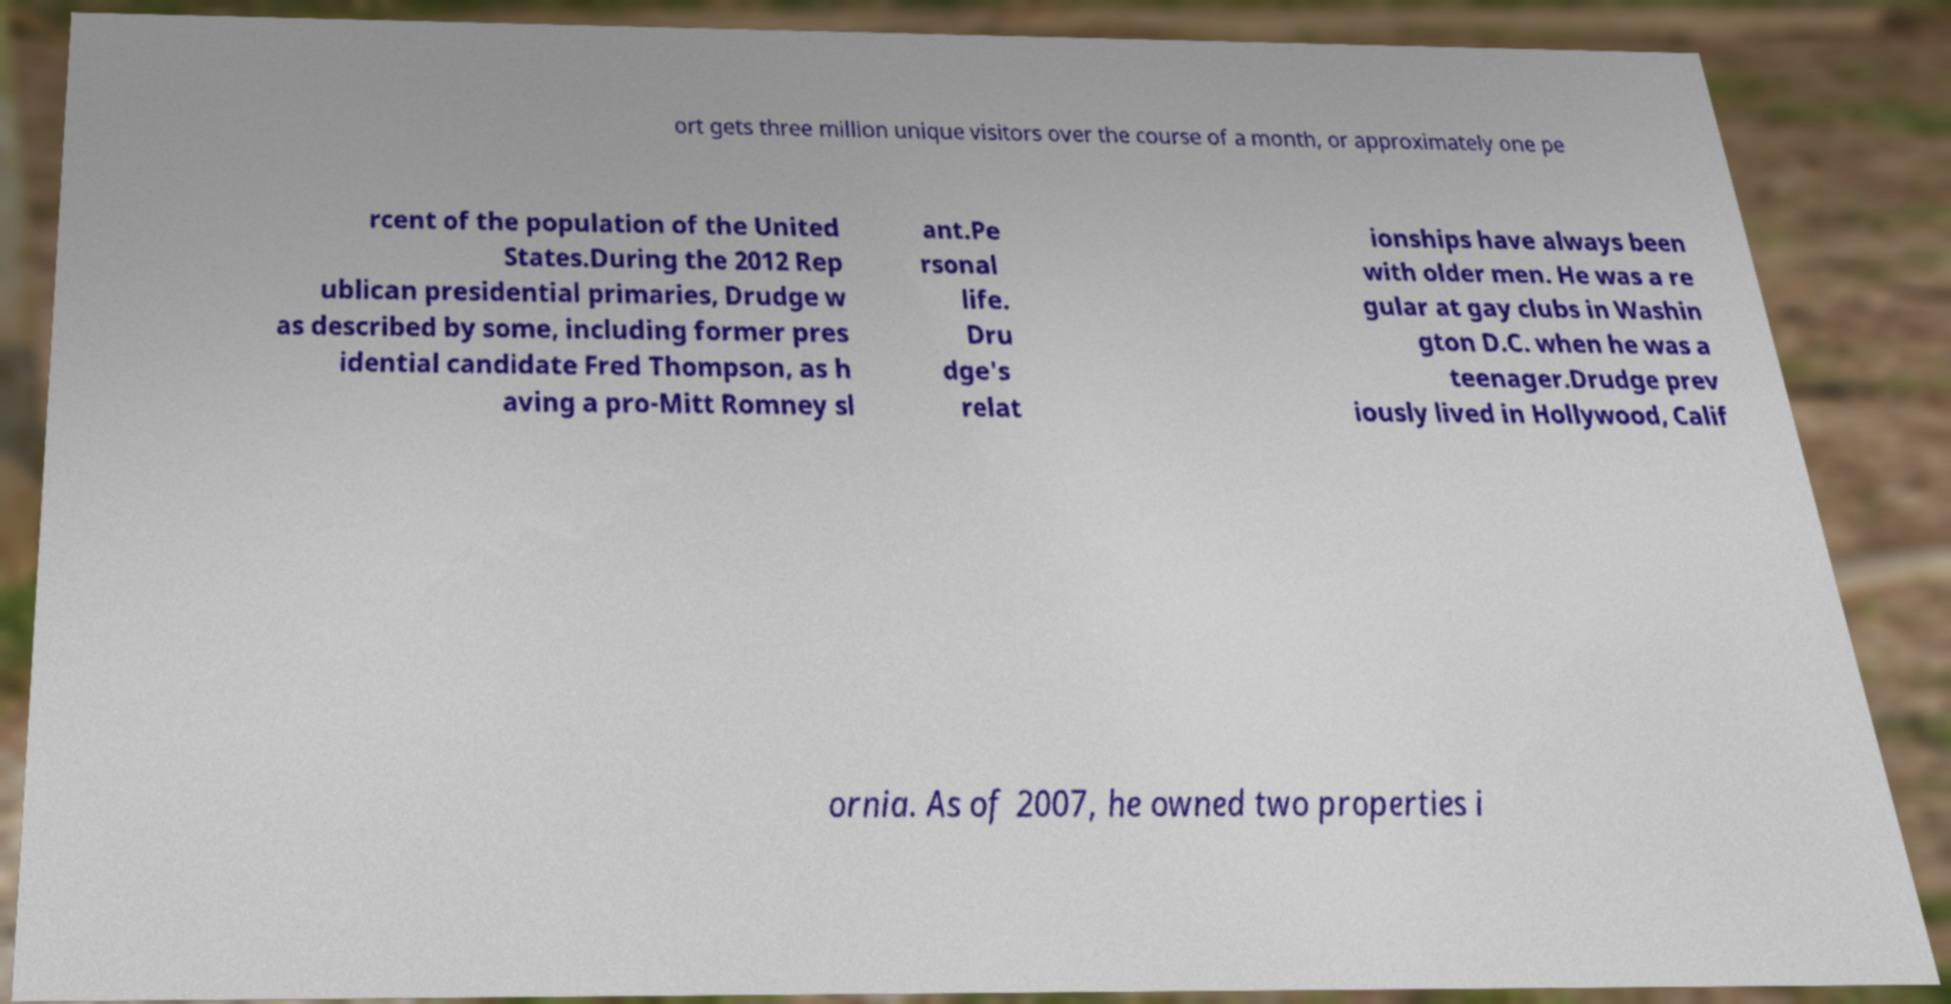Could you extract and type out the text from this image? ort gets three million unique visitors over the course of a month, or approximately one pe rcent of the population of the United States.During the 2012 Rep ublican presidential primaries, Drudge w as described by some, including former pres idential candidate Fred Thompson, as h aving a pro-Mitt Romney sl ant.Pe rsonal life. Dru dge's relat ionships have always been with older men. He was a re gular at gay clubs in Washin gton D.C. when he was a teenager.Drudge prev iously lived in Hollywood, Calif ornia. As of 2007, he owned two properties i 